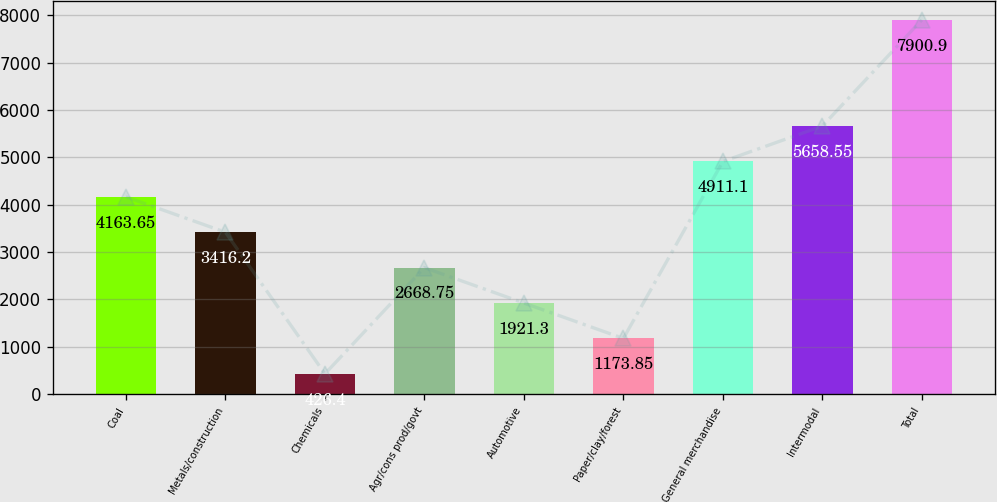Convert chart to OTSL. <chart><loc_0><loc_0><loc_500><loc_500><bar_chart><fcel>Coal<fcel>Metals/construction<fcel>Chemicals<fcel>Agr/cons prod/govt<fcel>Automotive<fcel>Paper/clay/forest<fcel>General merchandise<fcel>Intermodal<fcel>Total<nl><fcel>4163.65<fcel>3416.2<fcel>426.4<fcel>2668.75<fcel>1921.3<fcel>1173.85<fcel>4911.1<fcel>5658.55<fcel>7900.9<nl></chart> 